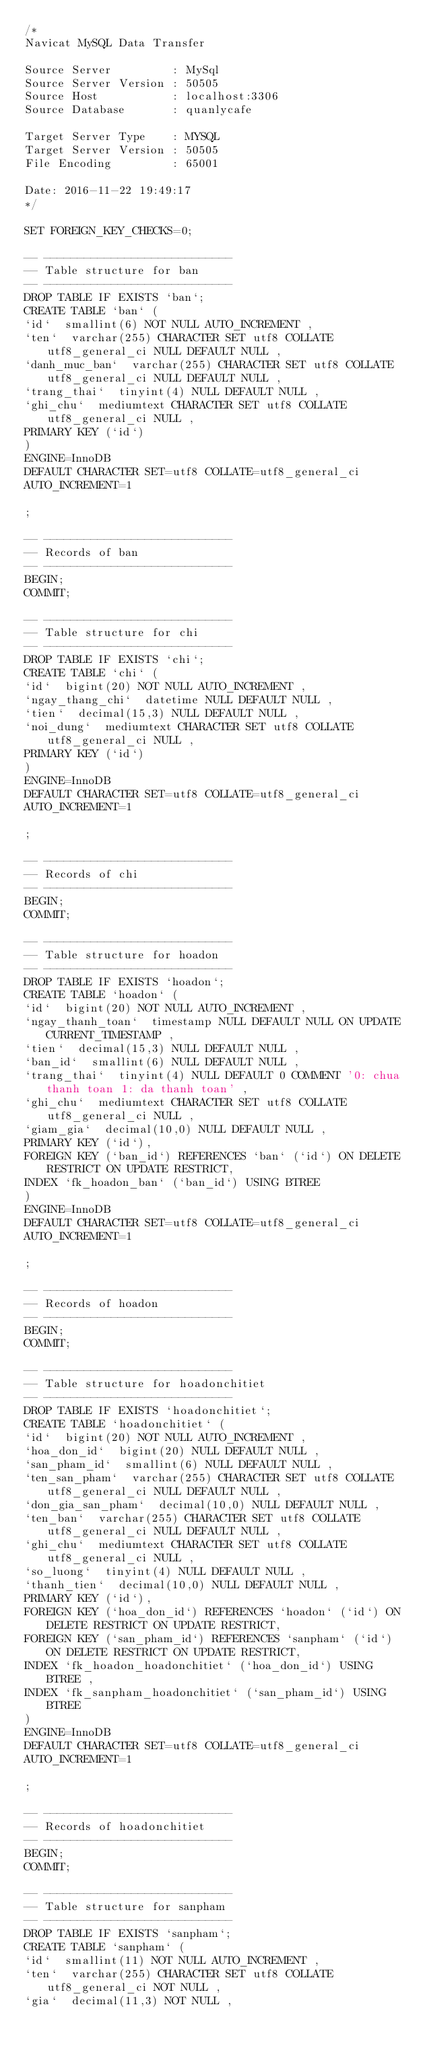Convert code to text. <code><loc_0><loc_0><loc_500><loc_500><_SQL_>/*
Navicat MySQL Data Transfer

Source Server         : MySql
Source Server Version : 50505
Source Host           : localhost:3306
Source Database       : quanlycafe

Target Server Type    : MYSQL
Target Server Version : 50505
File Encoding         : 65001

Date: 2016-11-22 19:49:17
*/

SET FOREIGN_KEY_CHECKS=0;

-- ----------------------------
-- Table structure for ban
-- ----------------------------
DROP TABLE IF EXISTS `ban`;
CREATE TABLE `ban` (
`id`  smallint(6) NOT NULL AUTO_INCREMENT ,
`ten`  varchar(255) CHARACTER SET utf8 COLLATE utf8_general_ci NULL DEFAULT NULL ,
`danh_muc_ban`  varchar(255) CHARACTER SET utf8 COLLATE utf8_general_ci NULL DEFAULT NULL ,
`trang_thai`  tinyint(4) NULL DEFAULT NULL ,
`ghi_chu`  mediumtext CHARACTER SET utf8 COLLATE utf8_general_ci NULL ,
PRIMARY KEY (`id`)
)
ENGINE=InnoDB
DEFAULT CHARACTER SET=utf8 COLLATE=utf8_general_ci
AUTO_INCREMENT=1

;

-- ----------------------------
-- Records of ban
-- ----------------------------
BEGIN;
COMMIT;

-- ----------------------------
-- Table structure for chi
-- ----------------------------
DROP TABLE IF EXISTS `chi`;
CREATE TABLE `chi` (
`id`  bigint(20) NOT NULL AUTO_INCREMENT ,
`ngay_thang_chi`  datetime NULL DEFAULT NULL ,
`tien`  decimal(15,3) NULL DEFAULT NULL ,
`noi_dung`  mediumtext CHARACTER SET utf8 COLLATE utf8_general_ci NULL ,
PRIMARY KEY (`id`)
)
ENGINE=InnoDB
DEFAULT CHARACTER SET=utf8 COLLATE=utf8_general_ci
AUTO_INCREMENT=1

;

-- ----------------------------
-- Records of chi
-- ----------------------------
BEGIN;
COMMIT;

-- ----------------------------
-- Table structure for hoadon
-- ----------------------------
DROP TABLE IF EXISTS `hoadon`;
CREATE TABLE `hoadon` (
`id`  bigint(20) NOT NULL AUTO_INCREMENT ,
`ngay_thanh_toan`  timestamp NULL DEFAULT NULL ON UPDATE CURRENT_TIMESTAMP ,
`tien`  decimal(15,3) NULL DEFAULT NULL ,
`ban_id`  smallint(6) NULL DEFAULT NULL ,
`trang_thai`  tinyint(4) NULL DEFAULT 0 COMMENT '0: chua thanh toan 1: da thanh toan' ,
`ghi_chu`  mediumtext CHARACTER SET utf8 COLLATE utf8_general_ci NULL ,
`giam_gia`  decimal(10,0) NULL DEFAULT NULL ,
PRIMARY KEY (`id`),
FOREIGN KEY (`ban_id`) REFERENCES `ban` (`id`) ON DELETE RESTRICT ON UPDATE RESTRICT,
INDEX `fk_hoadon_ban` (`ban_id`) USING BTREE 
)
ENGINE=InnoDB
DEFAULT CHARACTER SET=utf8 COLLATE=utf8_general_ci
AUTO_INCREMENT=1

;

-- ----------------------------
-- Records of hoadon
-- ----------------------------
BEGIN;
COMMIT;

-- ----------------------------
-- Table structure for hoadonchitiet
-- ----------------------------
DROP TABLE IF EXISTS `hoadonchitiet`;
CREATE TABLE `hoadonchitiet` (
`id`  bigint(20) NOT NULL AUTO_INCREMENT ,
`hoa_don_id`  bigint(20) NULL DEFAULT NULL ,
`san_pham_id`  smallint(6) NULL DEFAULT NULL ,
`ten_san_pham`  varchar(255) CHARACTER SET utf8 COLLATE utf8_general_ci NULL DEFAULT NULL ,
`don_gia_san_pham`  decimal(10,0) NULL DEFAULT NULL ,
`ten_ban`  varchar(255) CHARACTER SET utf8 COLLATE utf8_general_ci NULL DEFAULT NULL ,
`ghi_chu`  mediumtext CHARACTER SET utf8 COLLATE utf8_general_ci NULL ,
`so_luong`  tinyint(4) NULL DEFAULT NULL ,
`thanh_tien`  decimal(10,0) NULL DEFAULT NULL ,
PRIMARY KEY (`id`),
FOREIGN KEY (`hoa_don_id`) REFERENCES `hoadon` (`id`) ON DELETE RESTRICT ON UPDATE RESTRICT,
FOREIGN KEY (`san_pham_id`) REFERENCES `sanpham` (`id`) ON DELETE RESTRICT ON UPDATE RESTRICT,
INDEX `fk_hoadon_hoadonchitiet` (`hoa_don_id`) USING BTREE ,
INDEX `fk_sanpham_hoadonchitiet` (`san_pham_id`) USING BTREE 
)
ENGINE=InnoDB
DEFAULT CHARACTER SET=utf8 COLLATE=utf8_general_ci
AUTO_INCREMENT=1

;

-- ----------------------------
-- Records of hoadonchitiet
-- ----------------------------
BEGIN;
COMMIT;

-- ----------------------------
-- Table structure for sanpham
-- ----------------------------
DROP TABLE IF EXISTS `sanpham`;
CREATE TABLE `sanpham` (
`id`  smallint(11) NOT NULL AUTO_INCREMENT ,
`ten`  varchar(255) CHARACTER SET utf8 COLLATE utf8_general_ci NOT NULL ,
`gia`  decimal(11,3) NOT NULL ,</code> 